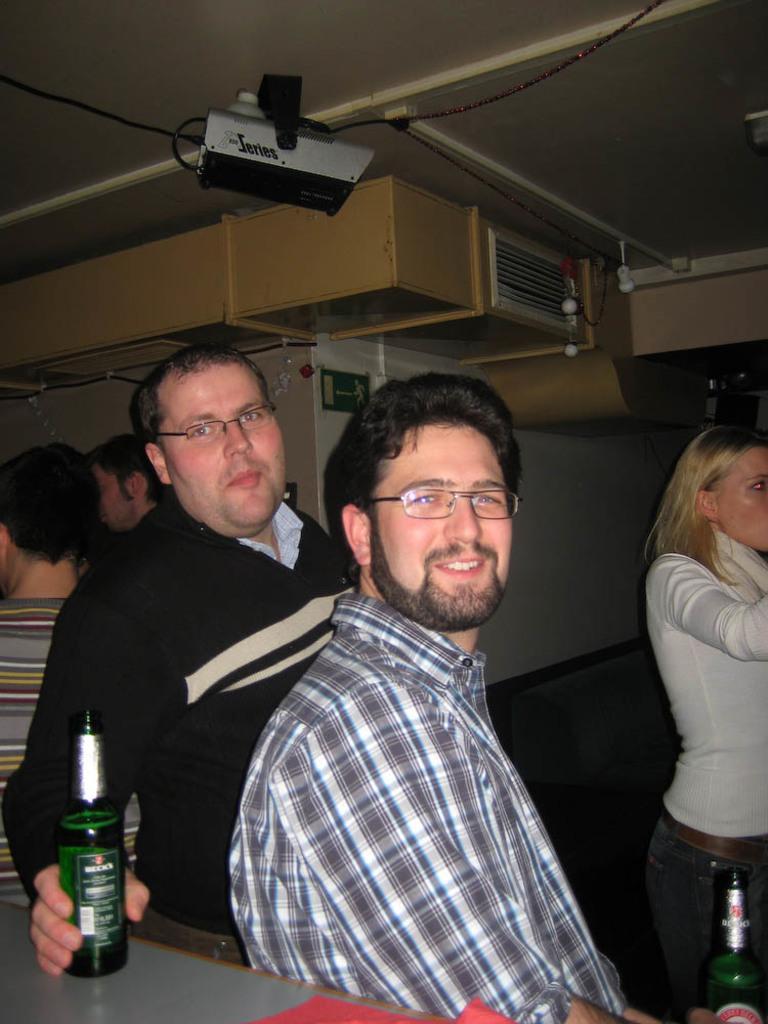In one or two sentences, can you explain what this image depicts? In the middle of the image two persons are standing and smiling and they are holding bottles. Bottom left side of the image there is a table. Top left side of the image two persons are standing. Behind them there is a wall. Bottom right side of the image a woman is standing. At the top of the image there is a roof and there is a electronic device. 